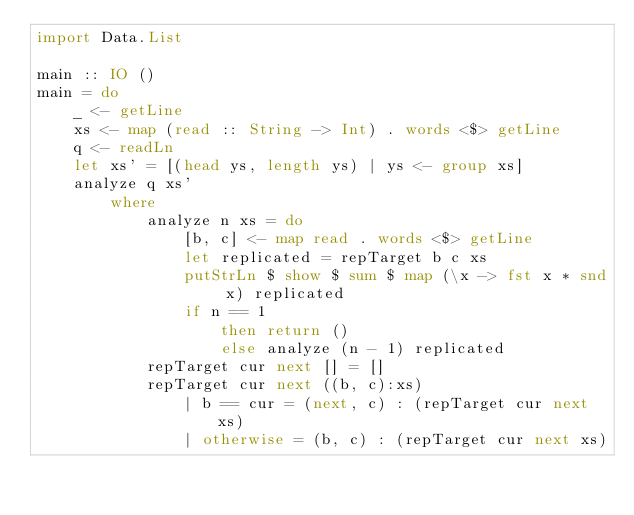Convert code to text. <code><loc_0><loc_0><loc_500><loc_500><_Haskell_>import Data.List

main :: IO ()
main = do
    _ <- getLine 
    xs <- map (read :: String -> Int) . words <$> getLine
    q <- readLn
    let xs' = [(head ys, length ys) | ys <- group xs]
    analyze q xs'
        where
            analyze n xs = do
                [b, c] <- map read . words <$> getLine
                let replicated = repTarget b c xs
                putStrLn $ show $ sum $ map (\x -> fst x * snd x) replicated
                if n == 1
                    then return ()
                    else analyze (n - 1) replicated
            repTarget cur next [] = []
            repTarget cur next ((b, c):xs)
                | b == cur = (next, c) : (repTarget cur next xs)
                | otherwise = (b, c) : (repTarget cur next xs)</code> 